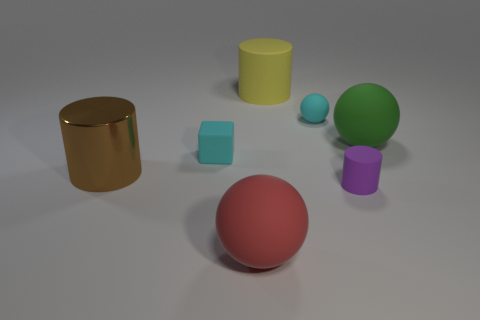Add 2 purple metallic blocks. How many objects exist? 9 Subtract all blocks. How many objects are left? 6 Subtract 0 blue balls. How many objects are left? 7 Subtract all yellow rubber cylinders. Subtract all big cylinders. How many objects are left? 4 Add 6 cyan matte objects. How many cyan matte objects are left? 8 Add 6 cyan rubber blocks. How many cyan rubber blocks exist? 7 